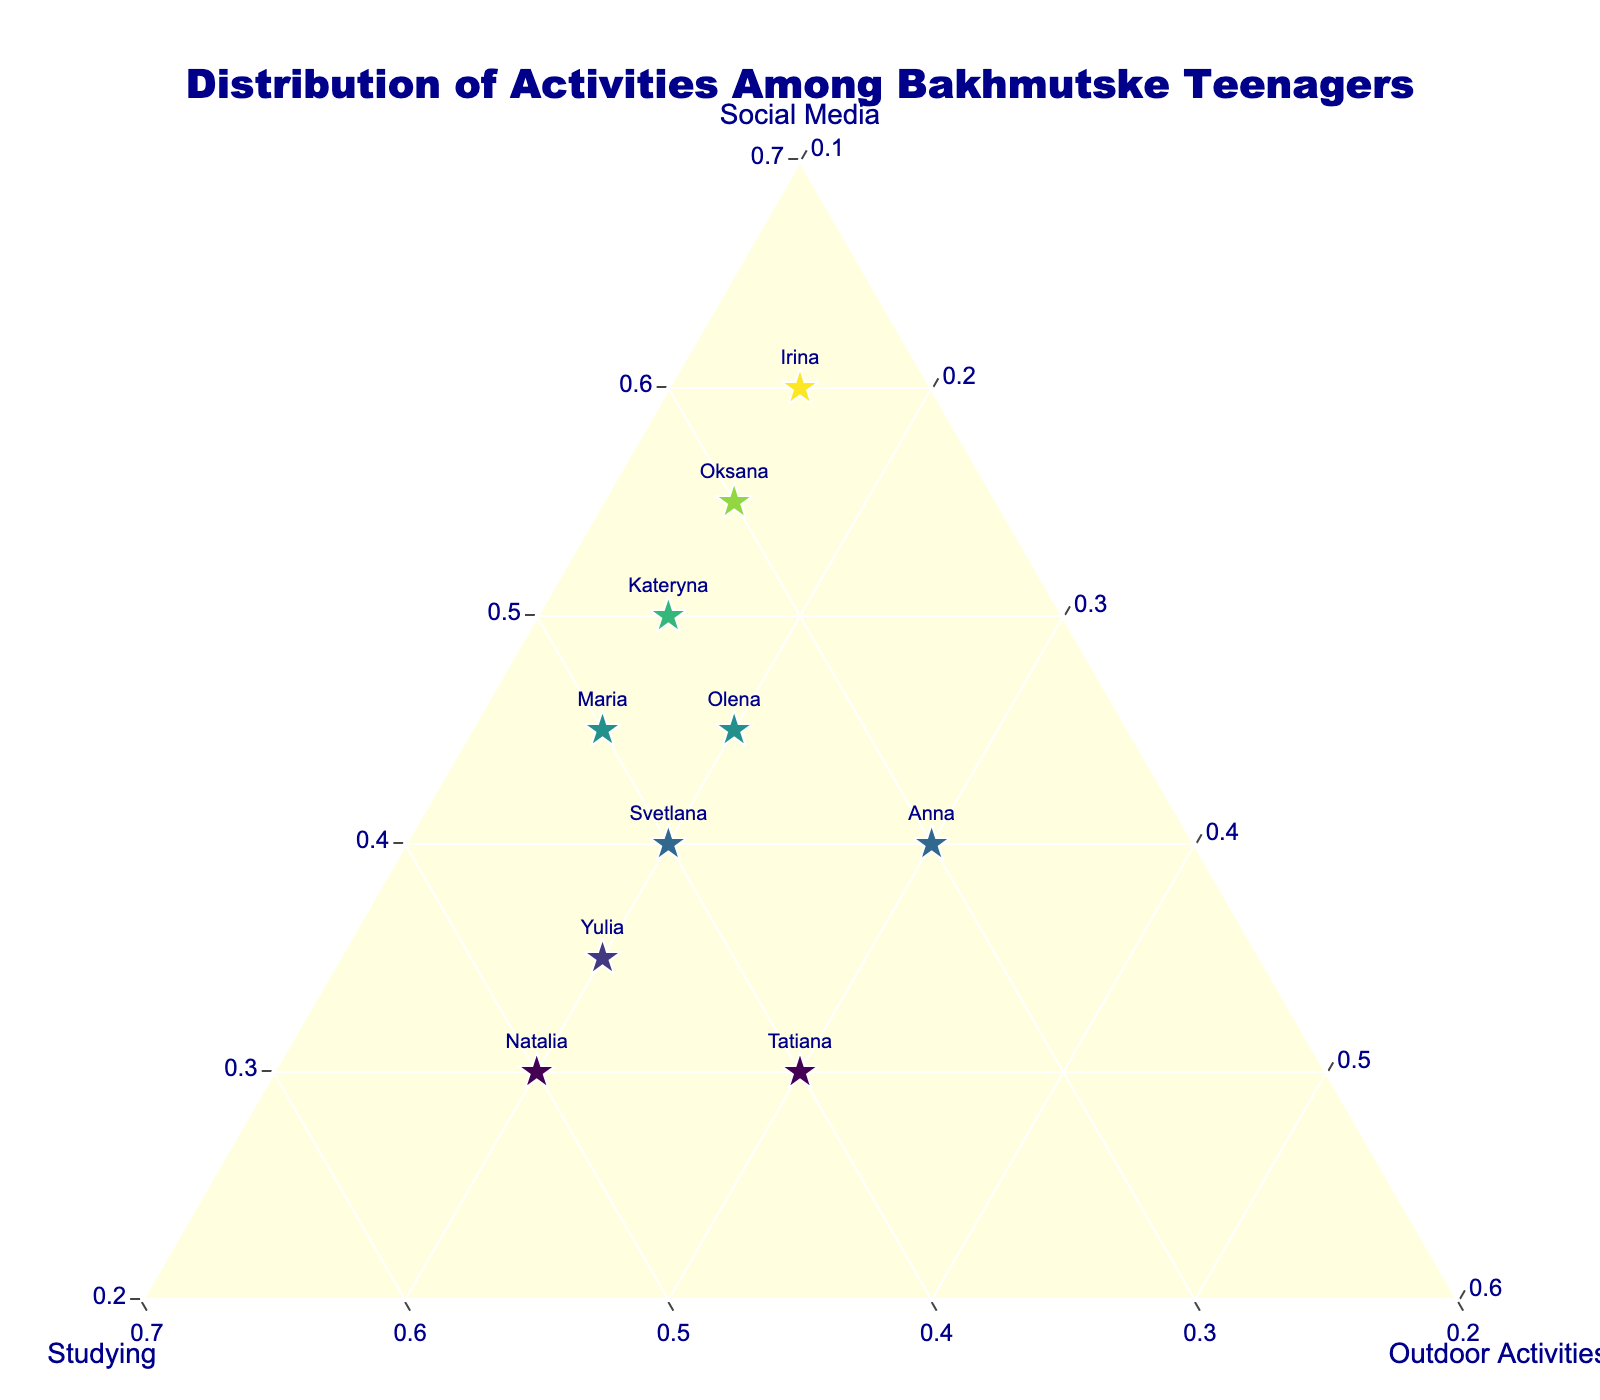Which activity does Anna spend the most time on? In the plot, Anna's point is positioned with values Social Media: 40, Studying: 30, Outdoor Activities: 30. The largest value is for Social Media.
Answer: Social Media How many teenagers spend more time on social media than Irina? Irina spends 60% of her time on Social Media. By looking at the plot, only one other teenager (Olena with 45, Oksana with 55, Kateryna with 50), all less than 60.
Answer: None What is the average percentage of time spent on studying among the teenagers? Summing up the time spent on studying by 10 teenagers: (35 + 50 + 25 + 40 + 30 + 45 + 35 + 30 + 40 + 40) = 370, then dividing by 10: 370 / 10 = 37
Answer: 37 Which two teenagers have the same percentage of time spent on outdoor activities? By looking at the plot, Olena, Natalia, Svetlana, and Yulia each spend 20% of their time on Outdoor Activities.
Answer: Olena and Yulia Who spends the least time on outdoor activities and what percentage is it? Observing the plot, the least time spent on Outdoor Activities is 15%, by Irina, Oksana, Kateryna, and Maria.
Answer: Irina, Oksana, Kateryna, and Maria, 15% Which teenager shows a balanced distribution between Social Media and Studying? A balanced distribution means the values for Social Media and Studying are nearly equal. In the plot, Svetlana has Social Media: 40 and Studying: 40, which is balanced.
Answer: Svetlana How much more time does Natalia spend on studying compared to Oksana? Natalia spends 50% of her time on Studying, while Oksana spends 30%. The difference is 50 - 30 = 20.
Answer: 20 Which activity has the highest percentage for Tatiana? Tatiana's activities are Social Media: 30, Studying: 40, Outdoor Activities: 30. The highest is Studying at 40%.
Answer: Studying 